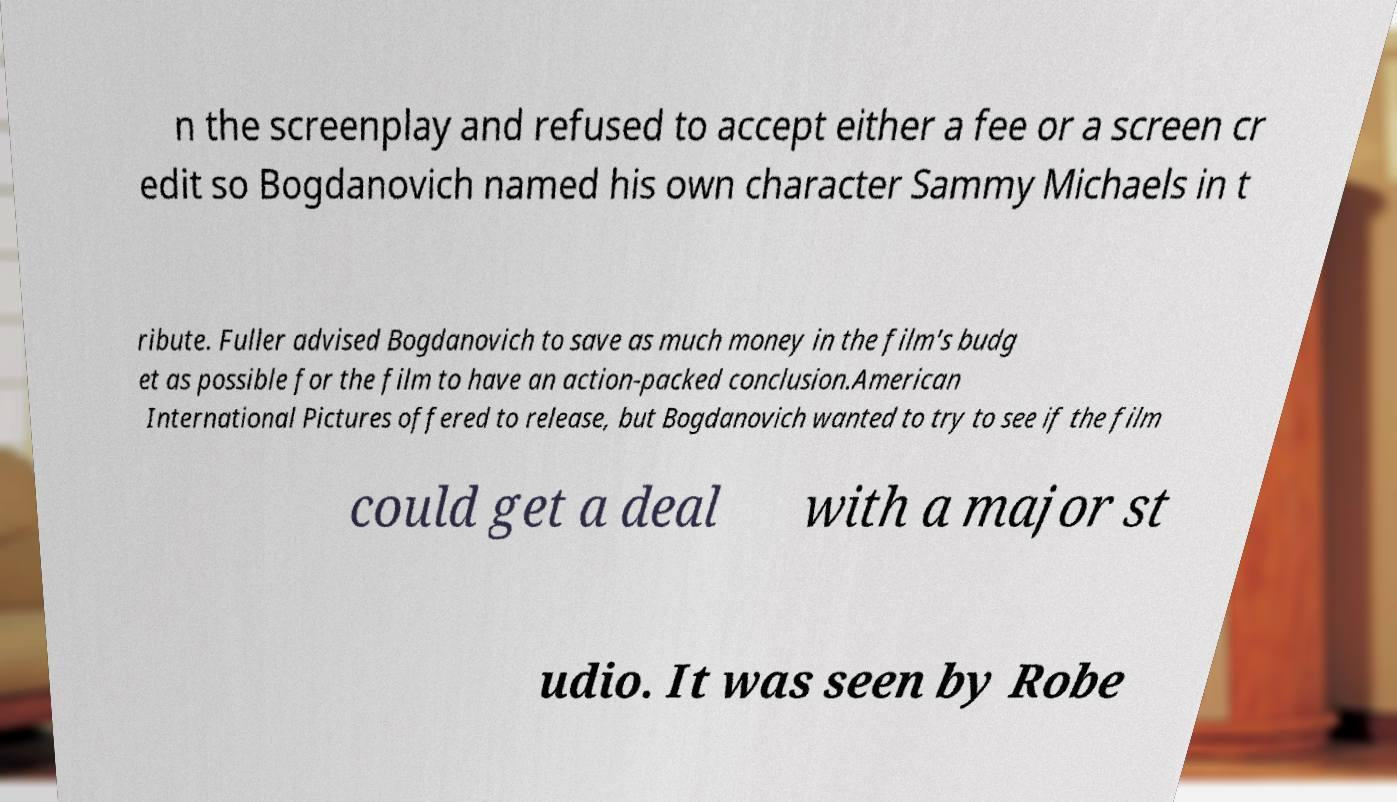Can you accurately transcribe the text from the provided image for me? n the screenplay and refused to accept either a fee or a screen cr edit so Bogdanovich named his own character Sammy Michaels in t ribute. Fuller advised Bogdanovich to save as much money in the film's budg et as possible for the film to have an action-packed conclusion.American International Pictures offered to release, but Bogdanovich wanted to try to see if the film could get a deal with a major st udio. It was seen by Robe 